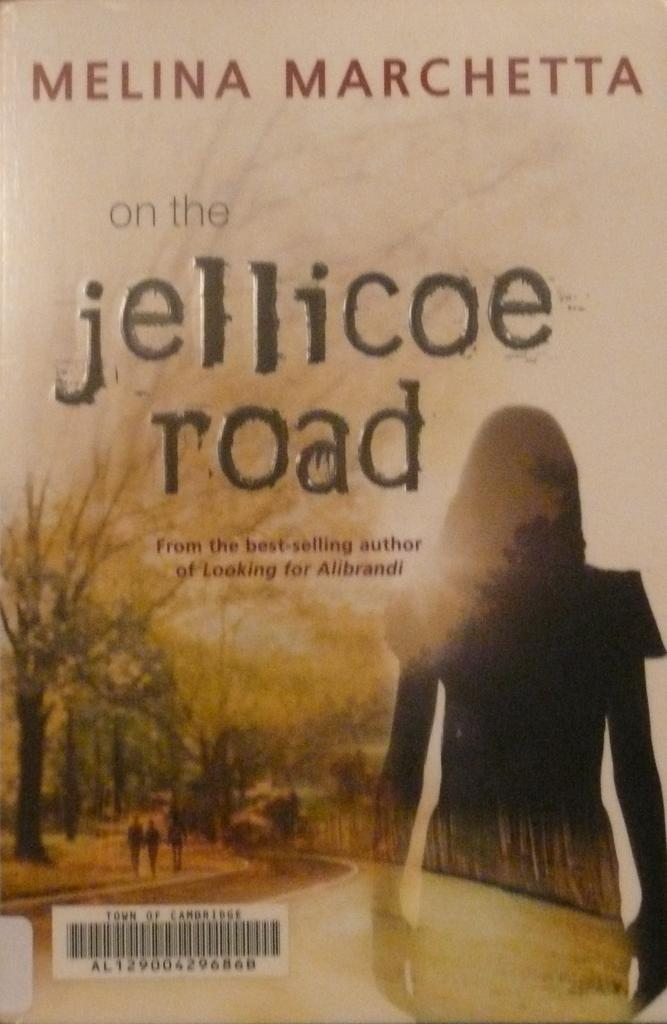<image>
Relay a brief, clear account of the picture shown. A paperback book is written by a best selling author named Melina Marchetta. 